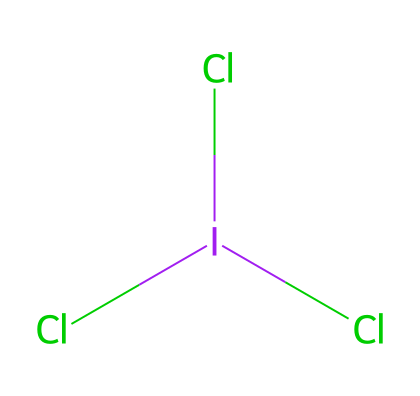What is the central atom in iodine trichloride? The central atom in the structure is indicated by the symbol "I" surrounded by three chlorine atoms represented by "Cl". This position in the structure shows it is at the center of three bonds.
Answer: I How many chlorine atoms are present in this compound? By examining the structure, it shows three chlorine atoms directly bonded to the central iodine atom, which is represented by the three "Cl" symbols.
Answer: 3 What is the molecular geometry of iodine trichloride? The arrangement of the three chlorine atoms around a single iodine atom, along with the presence of an unbonded electron pair on iodine, typically results in a trigonal pyramidal shape due to VSEPR theory.
Answer: trigonal pyramidal Does iodine trichloride exhibit hypervalency? The structure shows that iodine has expanded its valence shell to accommodate more than four pairs of electrons, as it forms three bonds with chlorine and can still have an additional lone pair.
Answer: Yes What is the total number of valence electrons in iodine trichloride? First, count the valence electrons from each atom: iodine (7) + 3 chlorine atoms (3×7=21) gives a total of 28 valence electrons.
Answer: 28 How many lone pairs does the iodine atom have in iodine trichloride? The iodine atom forms three bonds with the chlorine atoms, using three of its available valence electrons, leaving one lone pair remaining.
Answer: 1 Is iodine trichloride a polar or nonpolar molecule? The presence of three chlorine atoms creates an asymmetrical electron distribution around the iodine atom, leading to a dipole moment; thus, the molecule is polar due to its geometric structure.
Answer: polar 